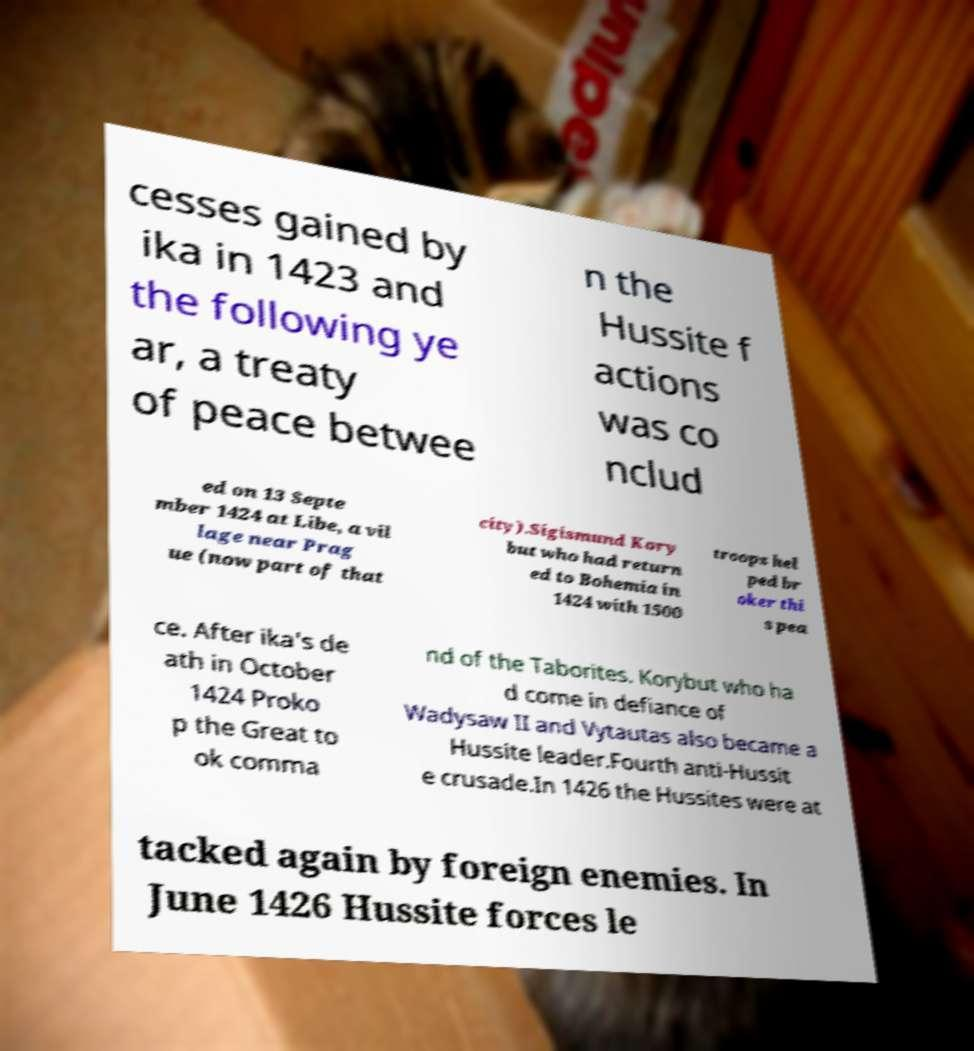I need the written content from this picture converted into text. Can you do that? cesses gained by ika in 1423 and the following ye ar, a treaty of peace betwee n the Hussite f actions was co nclud ed on 13 Septe mber 1424 at Libe, a vil lage near Prag ue (now part of that city).Sigismund Kory but who had return ed to Bohemia in 1424 with 1500 troops hel ped br oker thi s pea ce. After ika's de ath in October 1424 Proko p the Great to ok comma nd of the Taborites. Korybut who ha d come in defiance of Wadysaw II and Vytautas also became a Hussite leader.Fourth anti-Hussit e crusade.In 1426 the Hussites were at tacked again by foreign enemies. In June 1426 Hussite forces le 